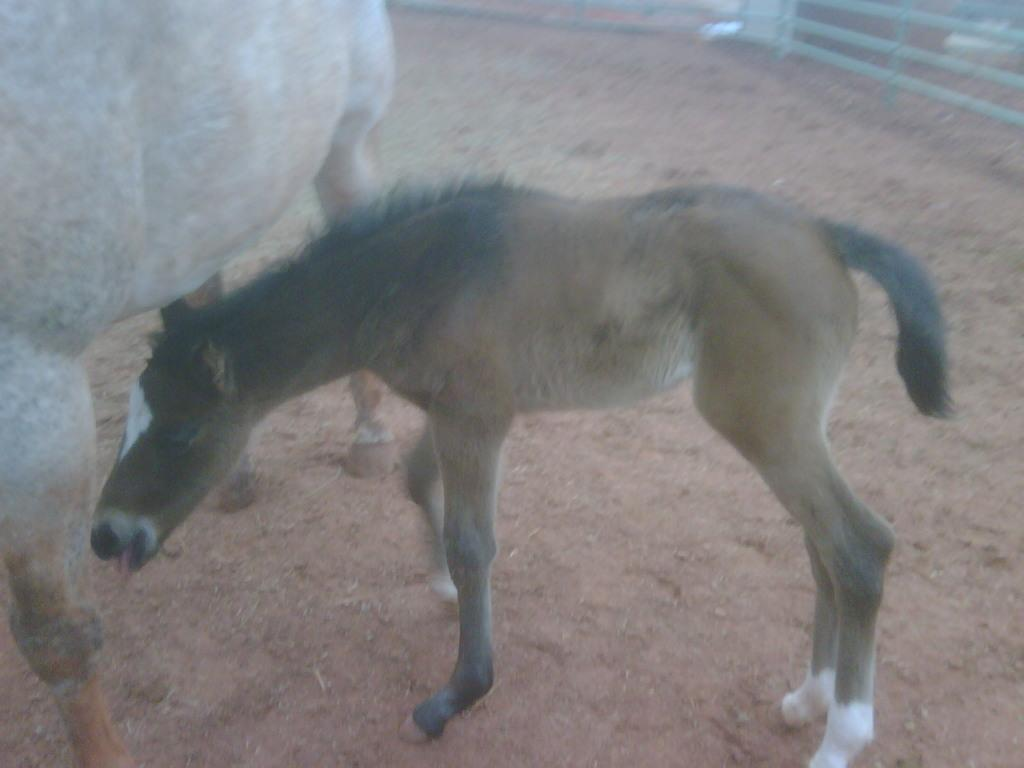What type of animal is in the image? There is a horse in the image. Can you describe the animal's position in the image? The horse is on the ground in the image. What type of structure can be seen in the image? There is a wooden railing visible in the image. What type of drain can be seen in the image? There is no drain present in the image. 